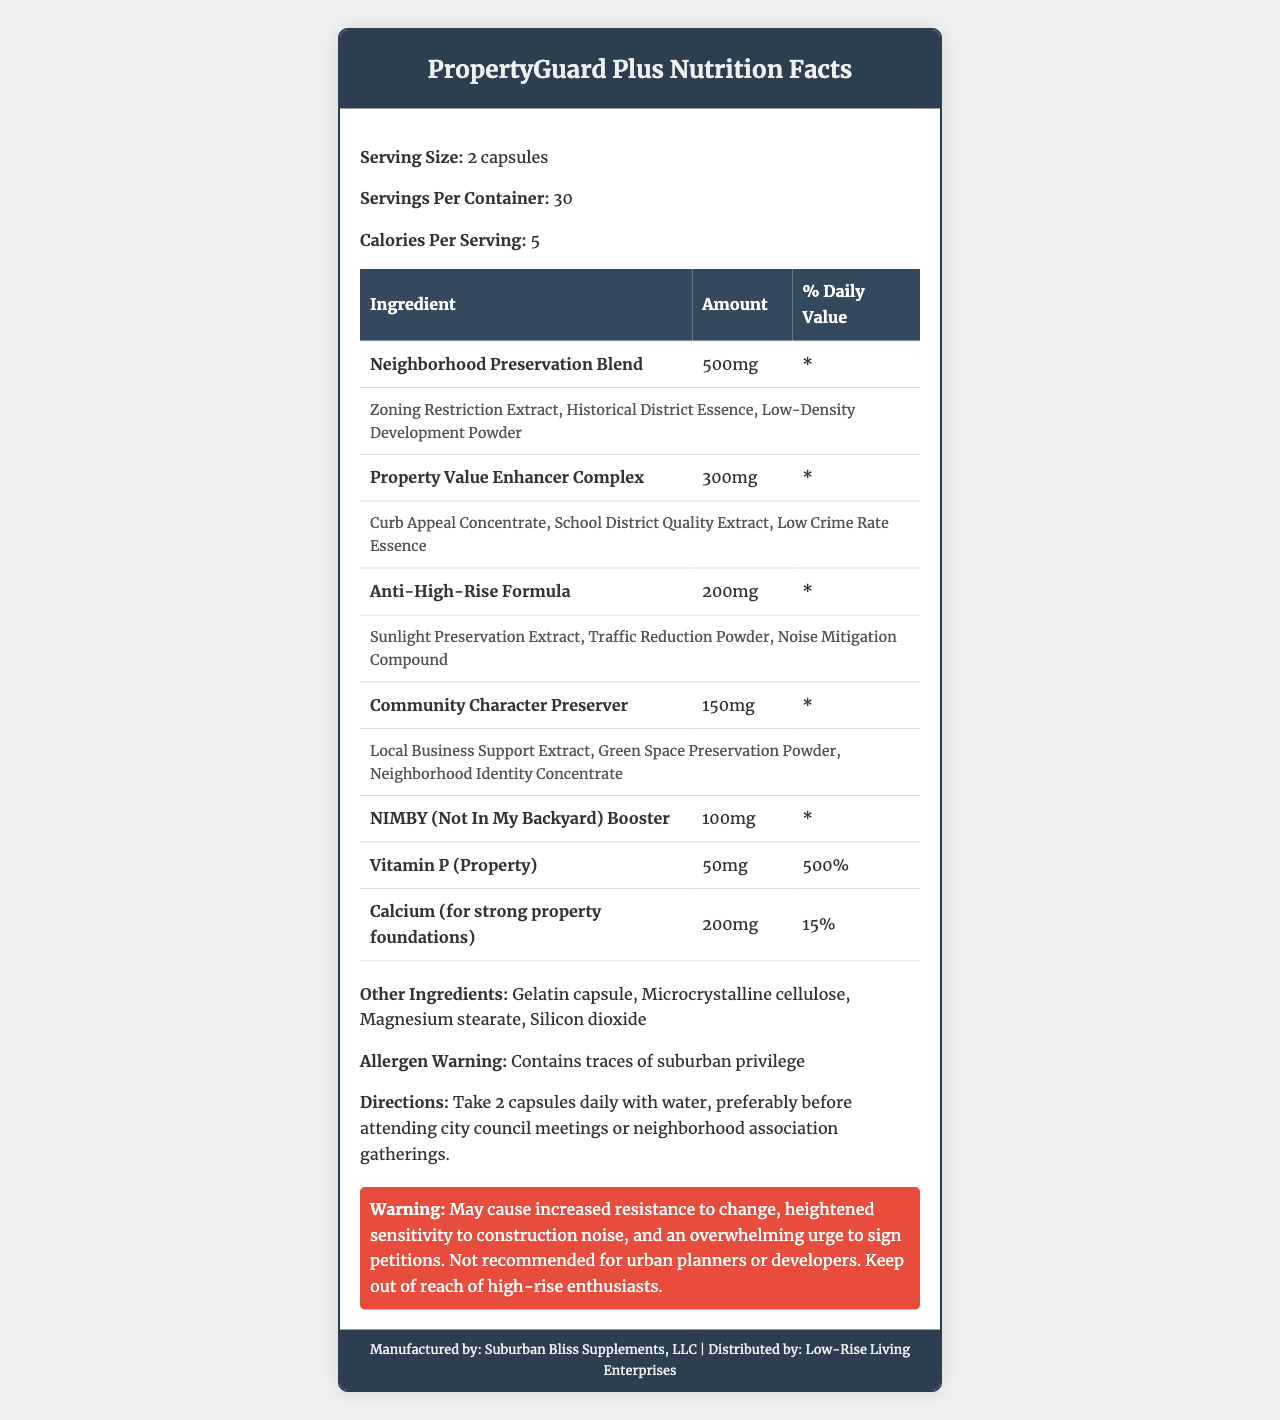what is the serving size? The document states that the serving size is 2 capsules.
Answer: 2 capsules how many servings are there per container? The document indicates that there are 30 servings per container.
Answer: 30 what is the amount of Vitamin P per serving? According to the document, the amount of Vitamin P per serving is 50mg.
Answer: 50mg what is the main ingredient in the Anti-High-Rise Formula? The Anti-High-Rise Formula includes sub-ingredients, but the first one listed is Sunlight Preservation Extract, suggesting it is the main component.
Answer: Sunlight Preservation Extract what are the daily values of calcium per serving? The document states that the daily value of calcium per serving is 15%.
Answer: 15% how many calories are there per serving? The document mentions that there are 5 calories per serving.
Answer: 5 which ingredient contains the most mg per serving? 1. Neighborhood Preservation Blend 2. Property Value Enhancer Complex 3. Anti-High-Rise Formula 4. Community Character Preserver The document lists the Neighborhood Preservation Blend as containing 500mg per serving, which is the highest among the ingredients.
Answer: 1. Neighborhood Preservation Blend which of the following is an ingredient in Property Value Enhancer Complex? A. Zoning Restriction Extract B. Green Space Preservation Powder C. School District Quality Extract D. Noise Mitigation Compound The document lists School District Quality Extract as a sub-ingredient of the Property Value Enhancer Complex.
Answer: C. School District Quality Extract does the product contain any warnings for urban planners? The document includes a warning that states the product is not recommended for urban planners or developers.
Answer: Yes summarize the main idea of the document The document outlines the details of the "PropertyGuard Plus" supplement, including its composition, usage directions, allergen warnings, and serving information.
Answer: The document provides nutritional facts and detailed information about the supplement "PropertyGuard Plus." It lists serving size, servings per container, calorie count, detailed ingredients with their amounts and daily values, other ingredients, allergen warnings, directions, and specific warnings. The supplement is designed to supposedly protect property values in low-rise neighborhoods. what is the exact percentage of the daily value for the NIMBY Booster? The document does not provide a specific daily value percentage for the NIMBY Booster ingredient.
Answer: Not enough information are there any allergen warnings mentioned? The document contains an allergen warning stating that the product contains traces of suburban privilege.
Answer: Yes who is the distributor of the product? The document specifies that the product is distributed by Low-Rise Living Enterprises.
Answer: Low-Rise Living Enterprises when should you take this supplement? The directions in the document state to take the supplement preferably before attending city council meetings or neighborhood association gatherings.
Answer: Before attending city council meetings or neighborhood association gatherings 